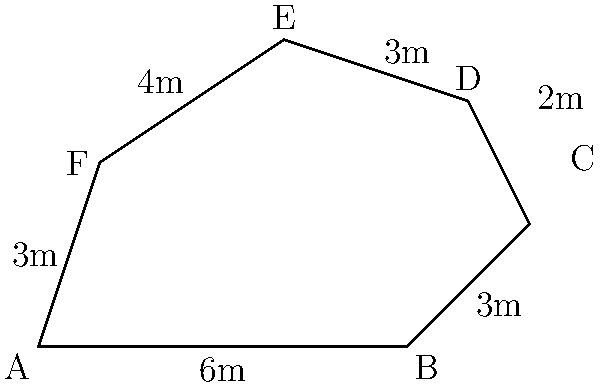You're designing a new dog park for your shelter friend. The park has an irregular shape, as shown in the diagram. If each side of the park is measured in meters, what is the total perimeter of the dog park? To calculate the perimeter of the dog park, we need to add up the lengths of all sides:

1. Side AB = 6m
2. Side BC = 3m
3. Side CD = 2m
4. Side DE = 3m
5. Side EF = 4m
6. Side FA = 3m

Now, let's add all these lengths together:

$$\text{Perimeter} = 6 + 3 + 2 + 3 + 4 + 3 = 21\text{ meters}$$

Therefore, the total perimeter of the dog park is 21 meters.
Answer: 21 meters 